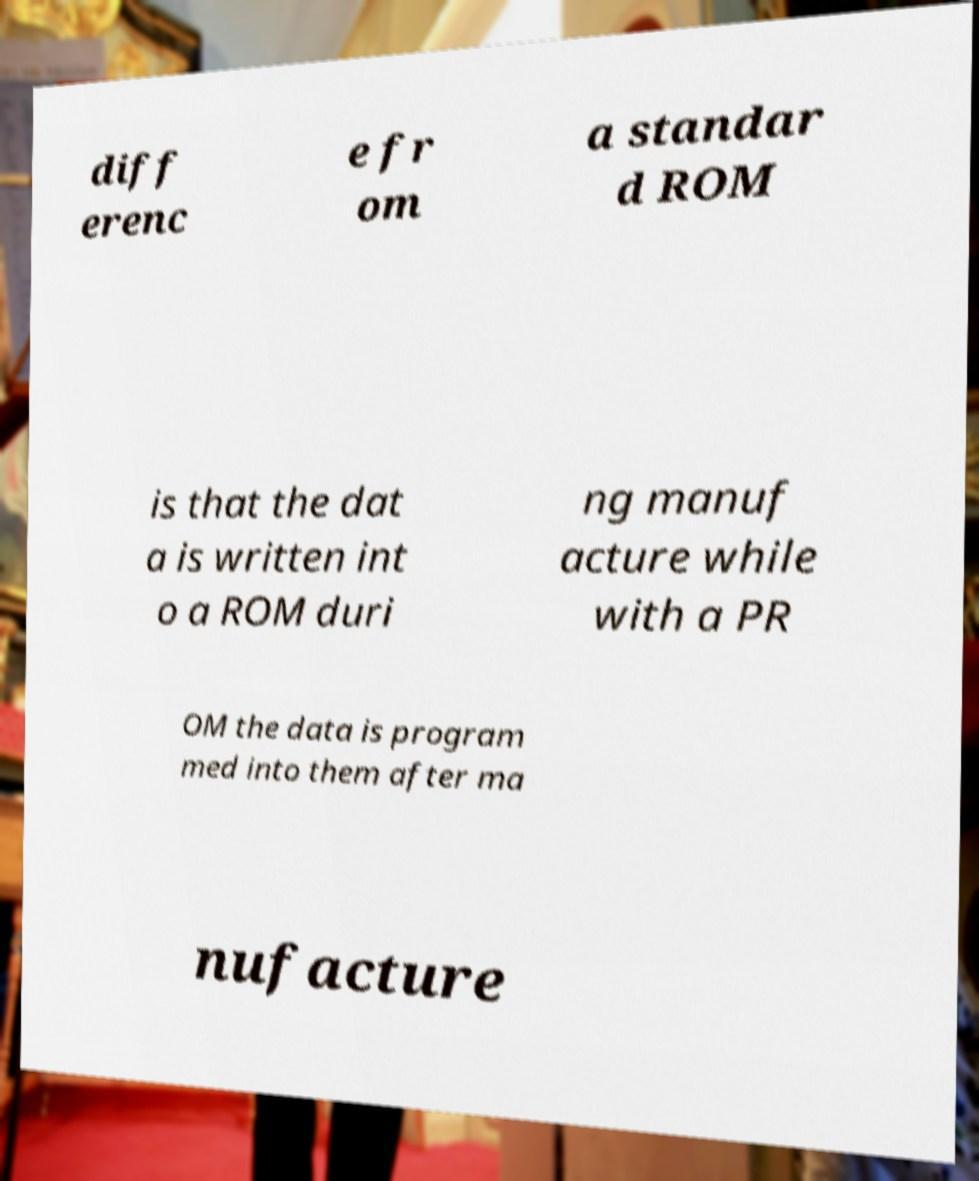There's text embedded in this image that I need extracted. Can you transcribe it verbatim? diff erenc e fr om a standar d ROM is that the dat a is written int o a ROM duri ng manuf acture while with a PR OM the data is program med into them after ma nufacture 